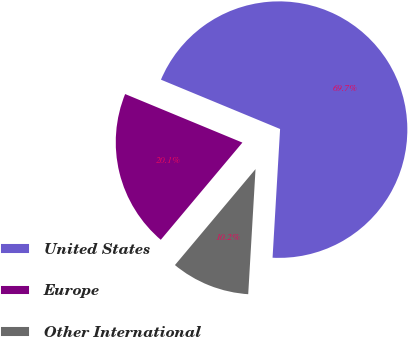Convert chart. <chart><loc_0><loc_0><loc_500><loc_500><pie_chart><fcel>United States<fcel>Europe<fcel>Other International<nl><fcel>69.69%<fcel>20.13%<fcel>10.19%<nl></chart> 